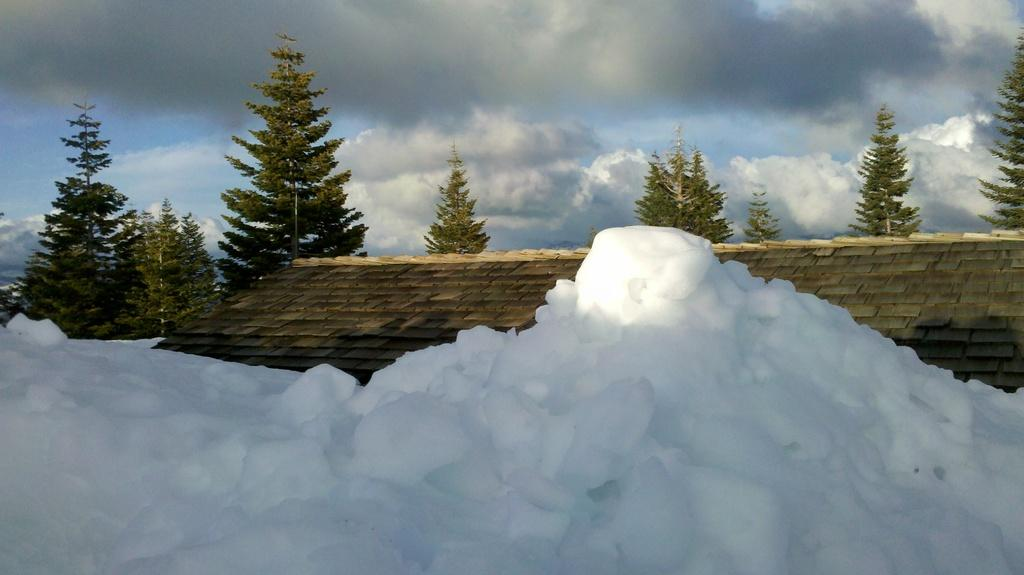What type of weather condition is depicted at the bottom of the image? There is snow at the bottom of the image. What can be seen in the background of the image? There is a wall and trees in the background of the image. What is visible at the top of the image? The sky is visible at the top of the image. What type of lipstick is being advertised in the image? There is no lipstick or advertisement present in the image. What is the name of the downtown area visible in the image? There is no downtown area visible in the image; it features snow, a wall, trees, and the sky. 